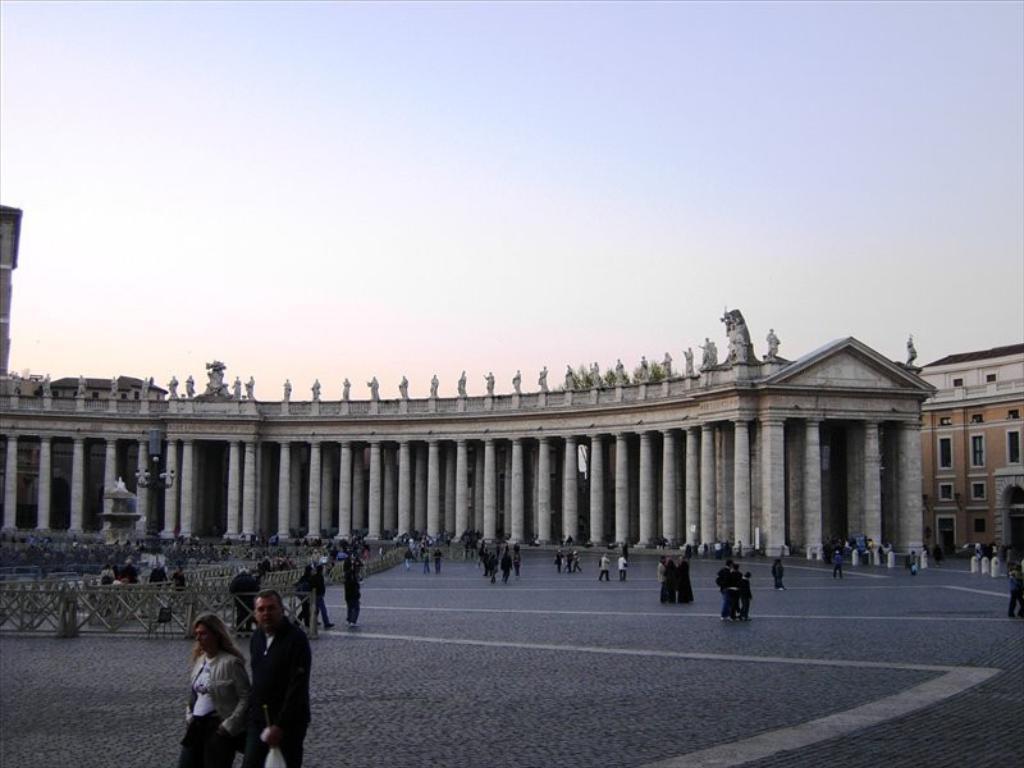Describe this image in one or two sentences. In the picture I can see the building on the right side. I can see the pillars of the construction and there are statues at the top of the construction. I can see a group of people on the road. There are clouds in the sky. I can see the wooden fencing on the road on the left side. 